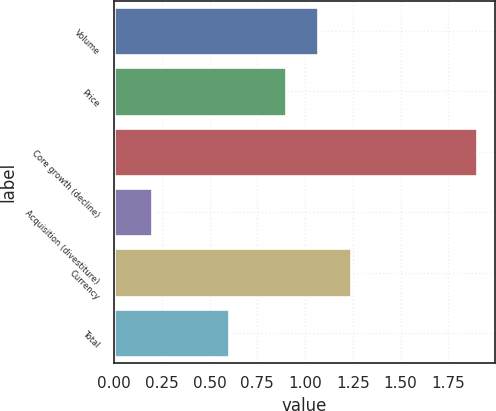Convert chart to OTSL. <chart><loc_0><loc_0><loc_500><loc_500><bar_chart><fcel>Volume<fcel>Price<fcel>Core growth (decline)<fcel>Acquisition (divestiture)<fcel>Currency<fcel>Total<nl><fcel>1.07<fcel>0.9<fcel>1.9<fcel>0.2<fcel>1.24<fcel>0.6<nl></chart> 